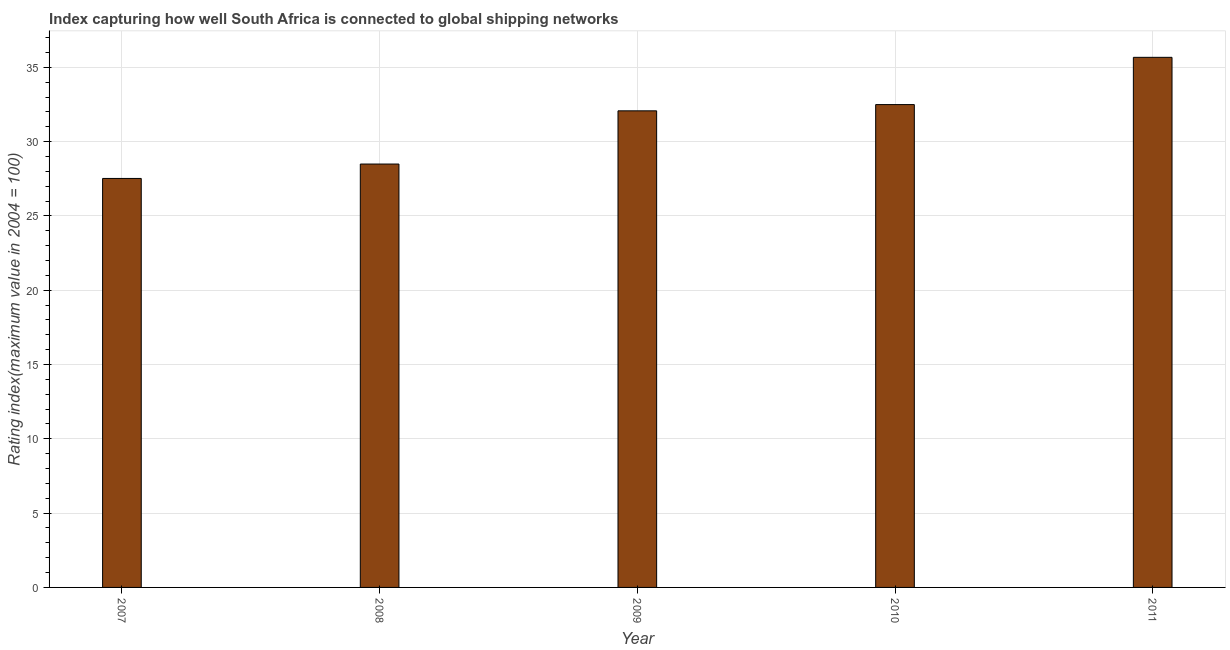What is the title of the graph?
Your response must be concise. Index capturing how well South Africa is connected to global shipping networks. What is the label or title of the X-axis?
Your response must be concise. Year. What is the label or title of the Y-axis?
Your answer should be very brief. Rating index(maximum value in 2004 = 100). What is the liner shipping connectivity index in 2010?
Ensure brevity in your answer.  32.49. Across all years, what is the maximum liner shipping connectivity index?
Provide a short and direct response. 35.67. Across all years, what is the minimum liner shipping connectivity index?
Ensure brevity in your answer.  27.52. In which year was the liner shipping connectivity index maximum?
Your response must be concise. 2011. In which year was the liner shipping connectivity index minimum?
Your answer should be compact. 2007. What is the sum of the liner shipping connectivity index?
Provide a short and direct response. 156.24. What is the difference between the liner shipping connectivity index in 2009 and 2010?
Your answer should be compact. -0.42. What is the average liner shipping connectivity index per year?
Ensure brevity in your answer.  31.25. What is the median liner shipping connectivity index?
Provide a short and direct response. 32.07. Do a majority of the years between 2010 and 2007 (inclusive) have liner shipping connectivity index greater than 8 ?
Make the answer very short. Yes. What is the ratio of the liner shipping connectivity index in 2008 to that in 2009?
Make the answer very short. 0.89. Is the difference between the liner shipping connectivity index in 2010 and 2011 greater than the difference between any two years?
Provide a short and direct response. No. What is the difference between the highest and the second highest liner shipping connectivity index?
Keep it short and to the point. 3.18. Is the sum of the liner shipping connectivity index in 2009 and 2010 greater than the maximum liner shipping connectivity index across all years?
Offer a very short reply. Yes. What is the difference between the highest and the lowest liner shipping connectivity index?
Keep it short and to the point. 8.15. In how many years, is the liner shipping connectivity index greater than the average liner shipping connectivity index taken over all years?
Your answer should be compact. 3. How many years are there in the graph?
Your response must be concise. 5. What is the difference between two consecutive major ticks on the Y-axis?
Provide a succinct answer. 5. What is the Rating index(maximum value in 2004 = 100) in 2007?
Ensure brevity in your answer.  27.52. What is the Rating index(maximum value in 2004 = 100) in 2008?
Provide a short and direct response. 28.49. What is the Rating index(maximum value in 2004 = 100) in 2009?
Offer a terse response. 32.07. What is the Rating index(maximum value in 2004 = 100) of 2010?
Your answer should be very brief. 32.49. What is the Rating index(maximum value in 2004 = 100) in 2011?
Provide a succinct answer. 35.67. What is the difference between the Rating index(maximum value in 2004 = 100) in 2007 and 2008?
Your answer should be compact. -0.97. What is the difference between the Rating index(maximum value in 2004 = 100) in 2007 and 2009?
Make the answer very short. -4.55. What is the difference between the Rating index(maximum value in 2004 = 100) in 2007 and 2010?
Provide a succinct answer. -4.97. What is the difference between the Rating index(maximum value in 2004 = 100) in 2007 and 2011?
Make the answer very short. -8.15. What is the difference between the Rating index(maximum value in 2004 = 100) in 2008 and 2009?
Provide a succinct answer. -3.58. What is the difference between the Rating index(maximum value in 2004 = 100) in 2008 and 2011?
Your answer should be compact. -7.18. What is the difference between the Rating index(maximum value in 2004 = 100) in 2009 and 2010?
Your answer should be compact. -0.42. What is the difference between the Rating index(maximum value in 2004 = 100) in 2009 and 2011?
Your response must be concise. -3.6. What is the difference between the Rating index(maximum value in 2004 = 100) in 2010 and 2011?
Provide a short and direct response. -3.18. What is the ratio of the Rating index(maximum value in 2004 = 100) in 2007 to that in 2009?
Offer a very short reply. 0.86. What is the ratio of the Rating index(maximum value in 2004 = 100) in 2007 to that in 2010?
Offer a terse response. 0.85. What is the ratio of the Rating index(maximum value in 2004 = 100) in 2007 to that in 2011?
Your answer should be very brief. 0.77. What is the ratio of the Rating index(maximum value in 2004 = 100) in 2008 to that in 2009?
Offer a terse response. 0.89. What is the ratio of the Rating index(maximum value in 2004 = 100) in 2008 to that in 2010?
Make the answer very short. 0.88. What is the ratio of the Rating index(maximum value in 2004 = 100) in 2008 to that in 2011?
Provide a short and direct response. 0.8. What is the ratio of the Rating index(maximum value in 2004 = 100) in 2009 to that in 2011?
Keep it short and to the point. 0.9. What is the ratio of the Rating index(maximum value in 2004 = 100) in 2010 to that in 2011?
Your response must be concise. 0.91. 